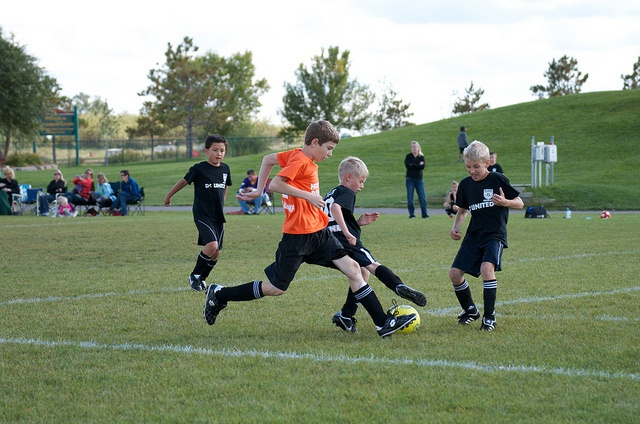Describe the objects in this image and their specific colors. I can see people in white, black, darkgray, and gray tones, people in white, black, gray, and darkgray tones, people in white, black, gray, and darkgray tones, people in white, black, gray, and olive tones, and people in white, black, navy, teal, and green tones in this image. 